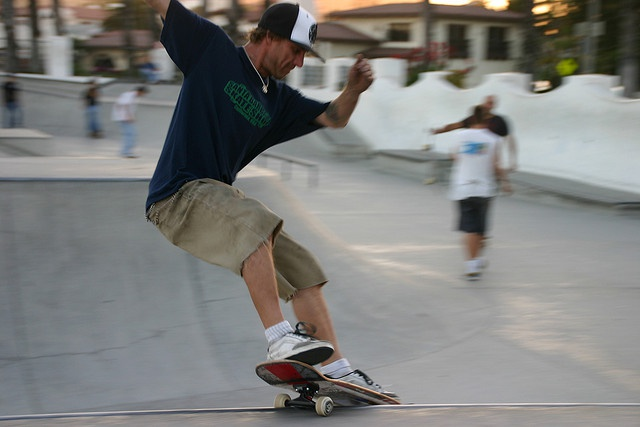Describe the objects in this image and their specific colors. I can see people in maroon, black, gray, and darkgray tones, people in maroon, darkgray, black, and gray tones, skateboard in maroon, black, gray, and darkgray tones, people in maroon, gray, and black tones, and people in maroon, darkgray, and gray tones in this image. 